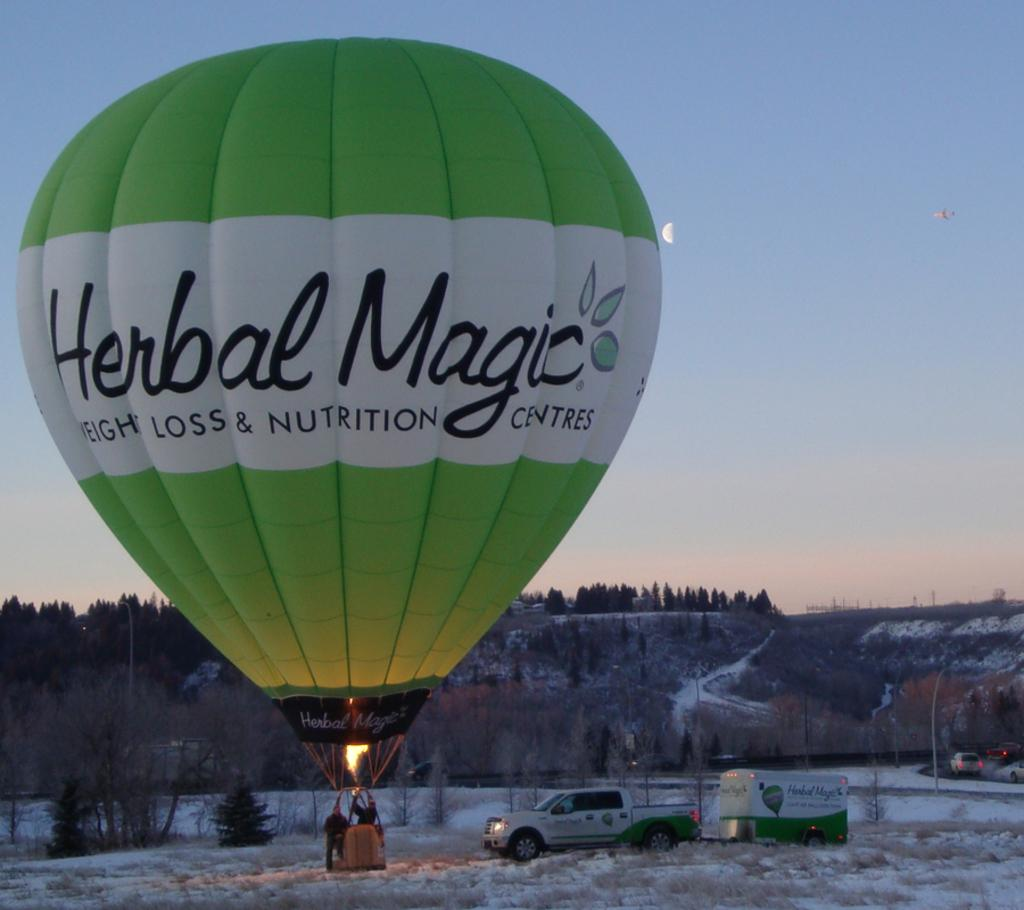What is the main subject in the center of the image? There is a parachute in the center of the image. Who or what is inside the parachute? There are people in the parachute. What can be seen at the bottom of the image? There are vehicles at the bottom of the image. What is the weather like in the image? Snow is visible in the image, indicating a cold or snowy environment. What is visible in the background of the image? There are trees and the sky in the background of the image. What type of pet can be seen rolling in the snow in the image? There is no pet visible in the image, and no one is rolling in the snow. 